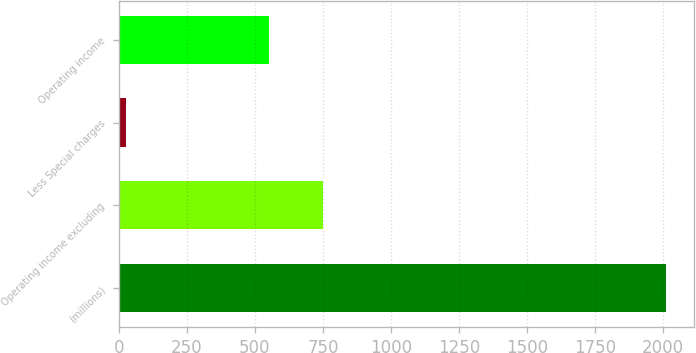Convert chart. <chart><loc_0><loc_0><loc_500><loc_500><bar_chart><fcel>(millions)<fcel>Operating income excluding<fcel>Less Special charges<fcel>Operating income<nl><fcel>2013<fcel>749.3<fcel>25<fcel>550.5<nl></chart> 